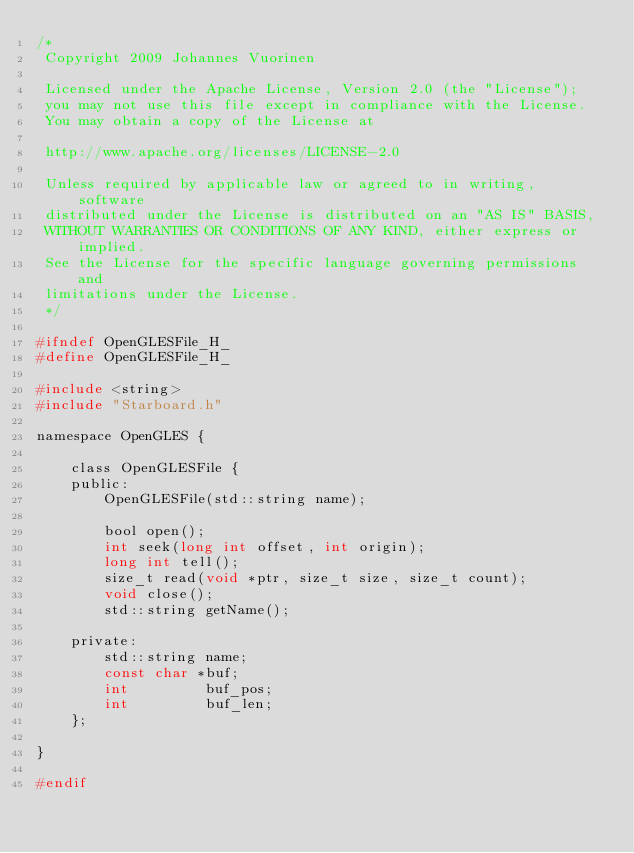<code> <loc_0><loc_0><loc_500><loc_500><_C_>/*
 Copyright 2009 Johannes Vuorinen
 
 Licensed under the Apache License, Version 2.0 (the "License");
 you may not use this file except in compliance with the License.
 You may obtain a copy of the License at 
 
 http://www.apache.org/licenses/LICENSE-2.0 
 
 Unless required by applicable law or agreed to in writing, software
 distributed under the License is distributed on an "AS IS" BASIS,
 WITHOUT WARRANTIES OR CONDITIONS OF ANY KIND, either express or implied.
 See the License for the specific language governing permissions and
 limitations under the License.
 */

#ifndef OpenGLESFile_H_
#define OpenGLESFile_H_

#include <string>
#include "Starboard.h"

namespace OpenGLES {
    
    class OpenGLESFile {
    public:
        OpenGLESFile(std::string name);
        
        bool open();
        int seek(long int offset, int origin);
        long int tell();
        size_t read(void *ptr, size_t size, size_t count);
        void close();
        std::string getName();
        
    private:
        std::string name;
        const char *buf;
        int         buf_pos;
        int         buf_len;
    };
    
}

#endif
</code> 